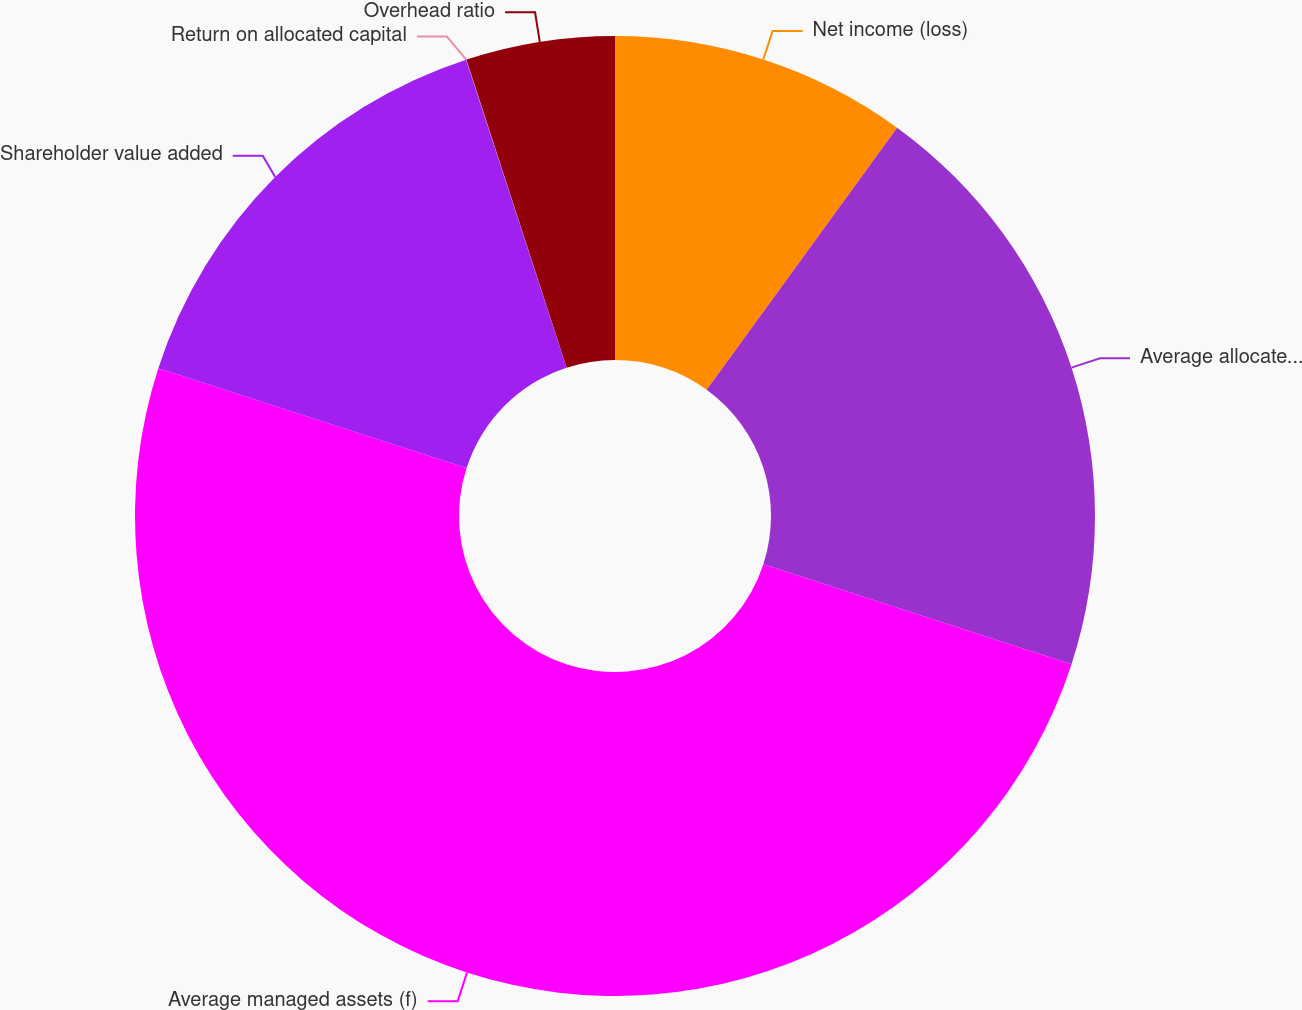Convert chart to OTSL. <chart><loc_0><loc_0><loc_500><loc_500><pie_chart><fcel>Net income (loss)<fcel>Average allocated capital<fcel>Average managed assets (f)<fcel>Shareholder value added<fcel>Return on allocated capital<fcel>Overhead ratio<nl><fcel>10.0%<fcel>20.0%<fcel>49.99%<fcel>15.0%<fcel>0.01%<fcel>5.01%<nl></chart> 